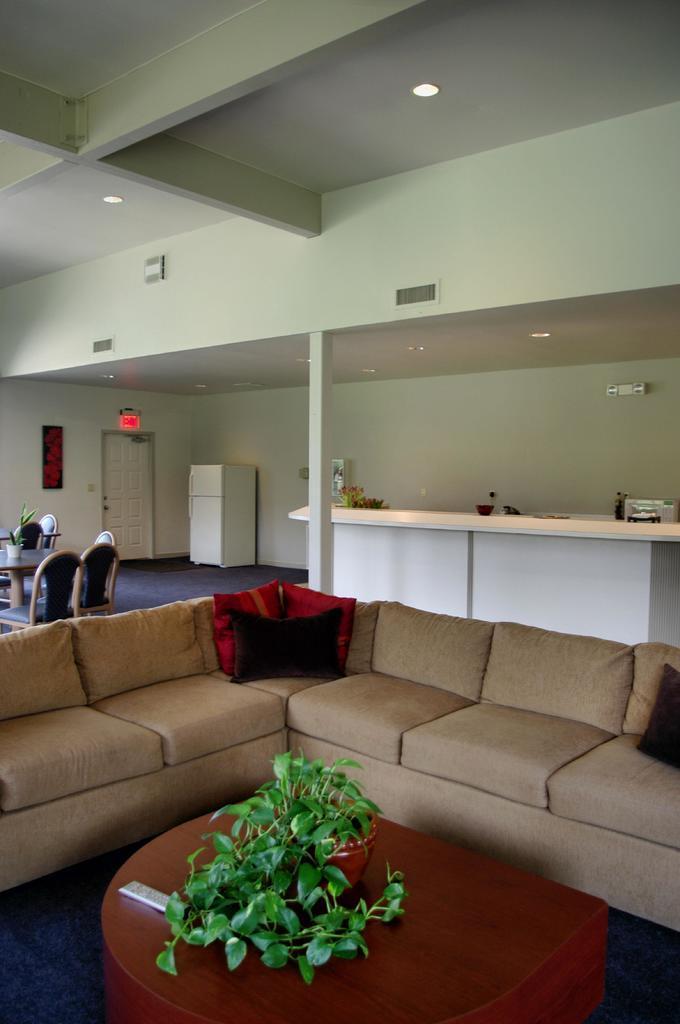How would you summarize this image in a sentence or two? This Image is clicked in a room where there are sofas in the middle. There is a table in the bottom, it has a plant on it. There is a dining table left side. There are lights on the top. 